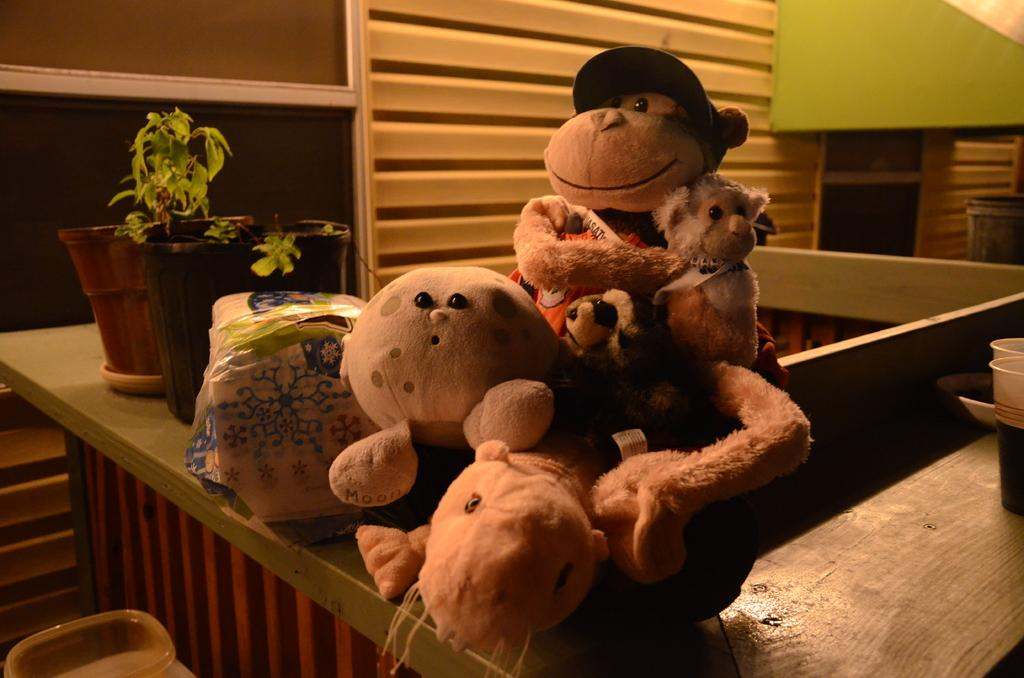What type of stuffed animals are in the image? There are teddy bears in the image. What other objects can be seen in the image? There are two flower pots in the image. What is the background of the image? There is a wall visible in the image. What type of music can be heard coming from the teddy bears in the image? There is no music coming from the teddy bears in the image, as they are stuffed animals and do not produce sound. 